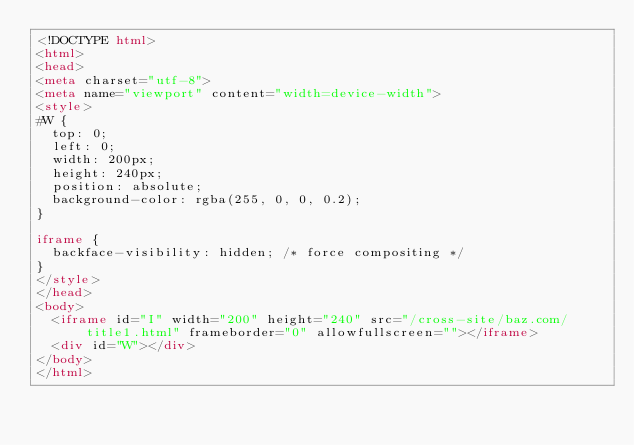Convert code to text. <code><loc_0><loc_0><loc_500><loc_500><_HTML_><!DOCTYPE html>
<html>
<head>
<meta charset="utf-8">
<meta name="viewport" content="width=device-width">
<style>
#W {
  top: 0;
  left: 0;
  width: 200px;
  height: 240px;
  position: absolute;
  background-color: rgba(255, 0, 0, 0.2);
}

iframe {
  backface-visibility: hidden; /* force compositing */
}
</style>
</head>
<body>
  <iframe id="I" width="200" height="240" src="/cross-site/baz.com/title1.html" frameborder="0" allowfullscreen=""></iframe>
  <div id="W"></div>
</body>
</html>
</code> 